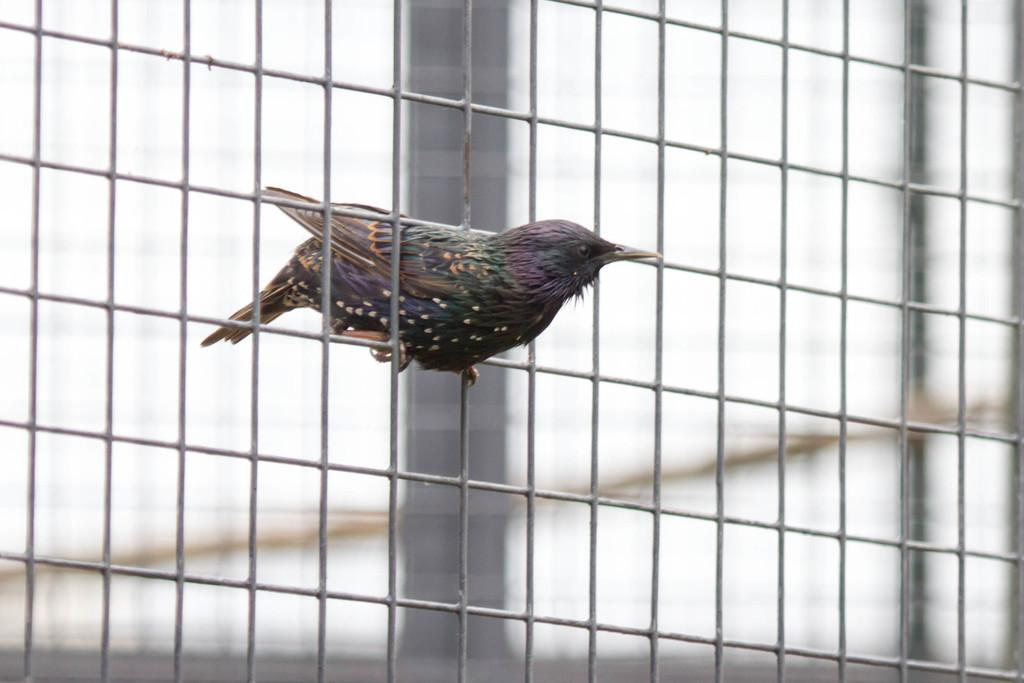What type of animal is in the image? There is a bird in the image. What is the bird standing on? The bird is standing on a cage. Where is the cage located in the image? The cage is in the front of the image. Can you describe the background of the image? The background of the image is blurry. Reasoning: Let' Let's think step by step in order to produce the conversation. We start by identifying the main subject in the image, which is the bird. Then, we describe the bird's position and the object it is standing on, which is a cage. Next, we specify the location of the cage in the image, stating that it is in the front. Finally, we mention the background of the image, noting that it is blurry. Each question is designed to elicit a specific detail about the image that is known from the provided facts. Absurd Question/Answer: How many rabbits are playing with a kite in the background of the image? There are no rabbits or kites present in the image; it features a bird standing on a cage with a blurry background. What type of home does the bird live in, as seen in the image? The image does not show the bird's home; it only shows the bird standing on a cage in the front of the image. 